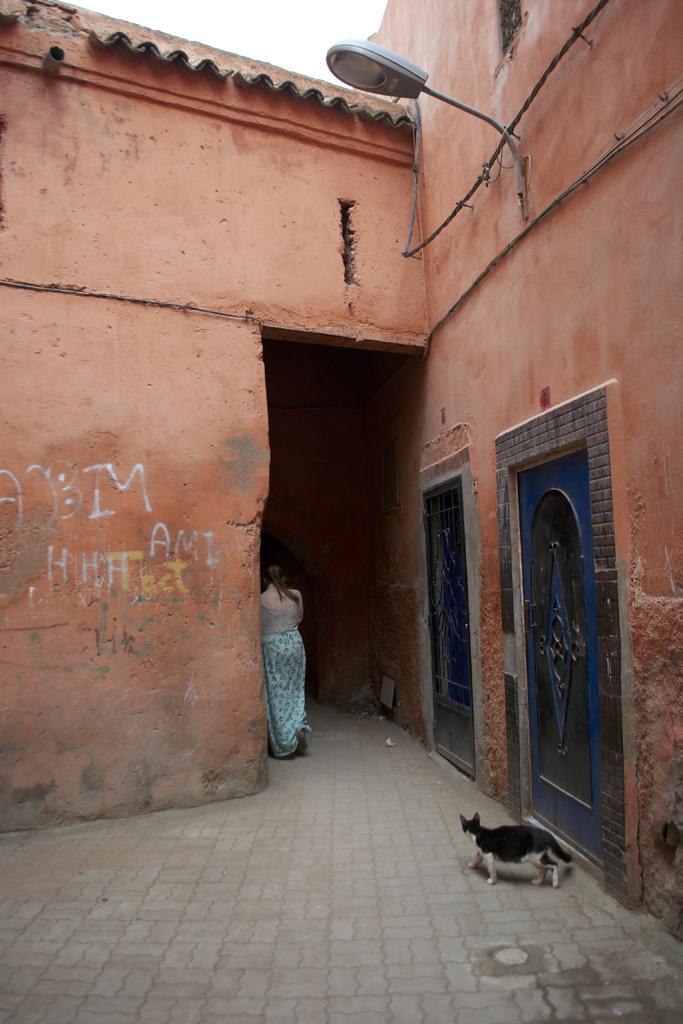Describe this image in one or two sentences. In this image there is one person standing in middle of this image and there is a house as we can see in middle of this image. There is one cat at bottom of this image. There is a bulb at top right corner of this image , and there are two doors at right side of this image and there is a sky at top of this image. 